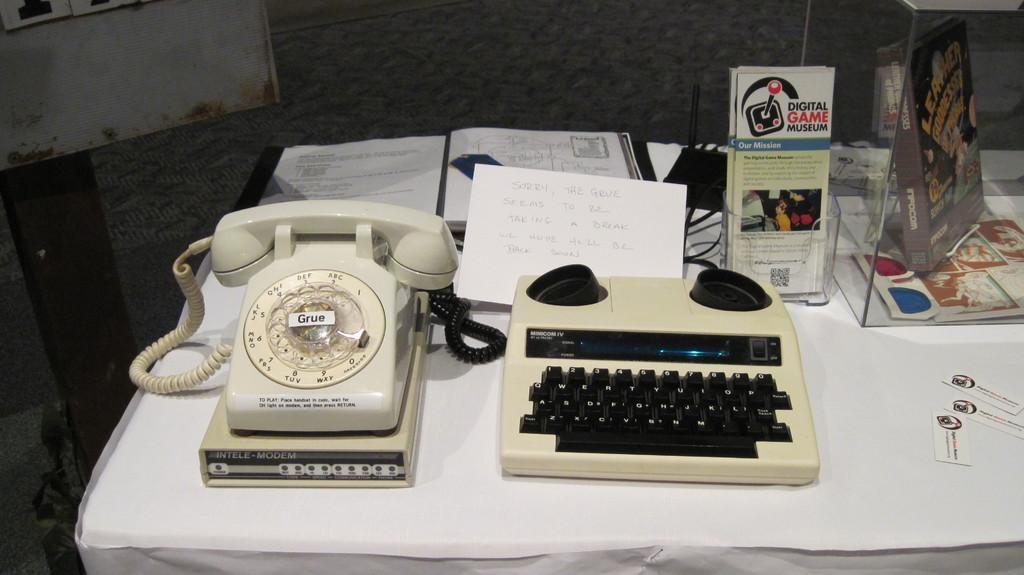In one or two sentences, can you explain what this image depicts? On the left side there is a telephone there are books in the middle of an image. 